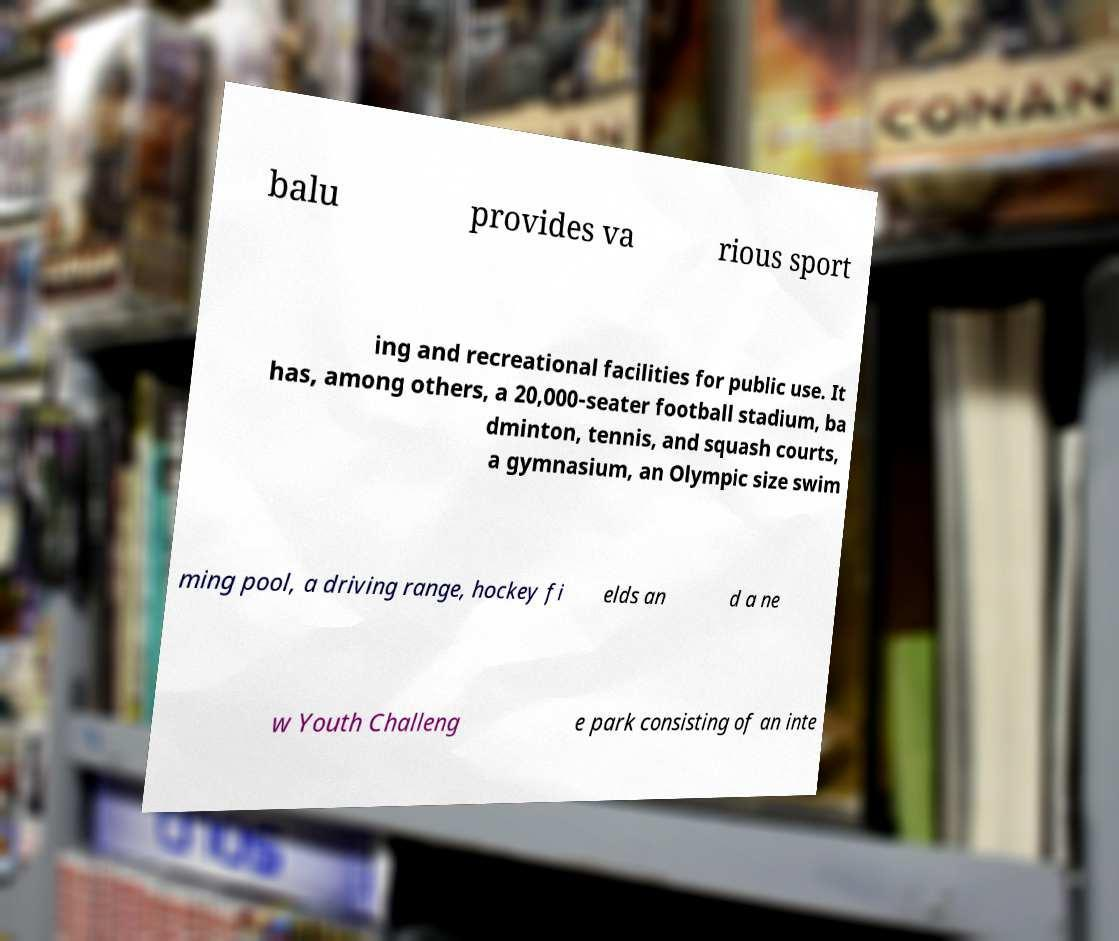There's text embedded in this image that I need extracted. Can you transcribe it verbatim? balu provides va rious sport ing and recreational facilities for public use. It has, among others, a 20,000-seater football stadium, ba dminton, tennis, and squash courts, a gymnasium, an Olympic size swim ming pool, a driving range, hockey fi elds an d a ne w Youth Challeng e park consisting of an inte 